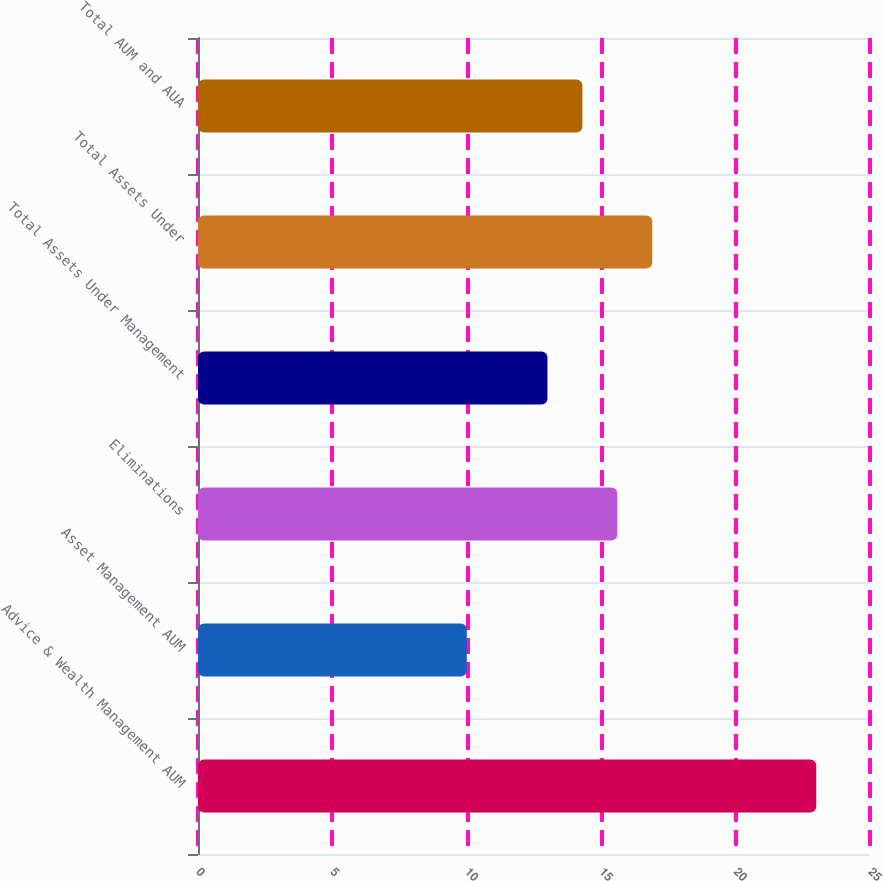Convert chart to OTSL. <chart><loc_0><loc_0><loc_500><loc_500><bar_chart><fcel>Advice & Wealth Management AUM<fcel>Asset Management AUM<fcel>Eliminations<fcel>Total Assets Under Management<fcel>Total Assets Under<fcel>Total AUM and AUA<nl><fcel>23<fcel>10<fcel>15.6<fcel>13<fcel>16.9<fcel>14.3<nl></chart> 